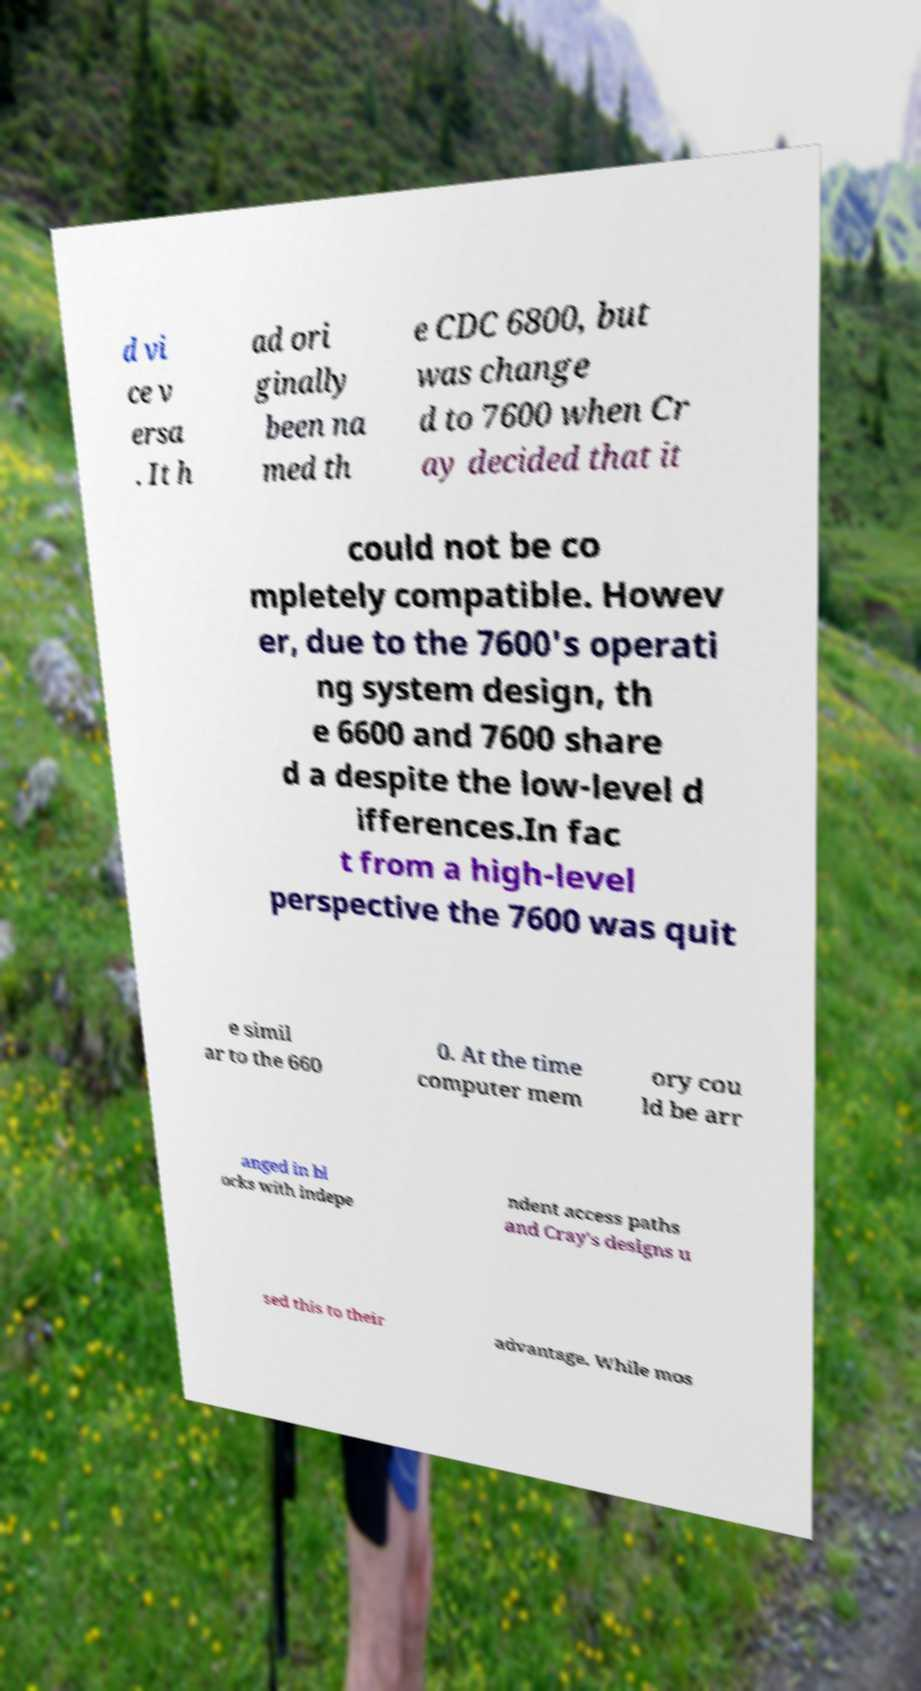Can you accurately transcribe the text from the provided image for me? d vi ce v ersa . It h ad ori ginally been na med th e CDC 6800, but was change d to 7600 when Cr ay decided that it could not be co mpletely compatible. Howev er, due to the 7600's operati ng system design, th e 6600 and 7600 share d a despite the low-level d ifferences.In fac t from a high-level perspective the 7600 was quit e simil ar to the 660 0. At the time computer mem ory cou ld be arr anged in bl ocks with indepe ndent access paths and Cray's designs u sed this to their advantage. While mos 